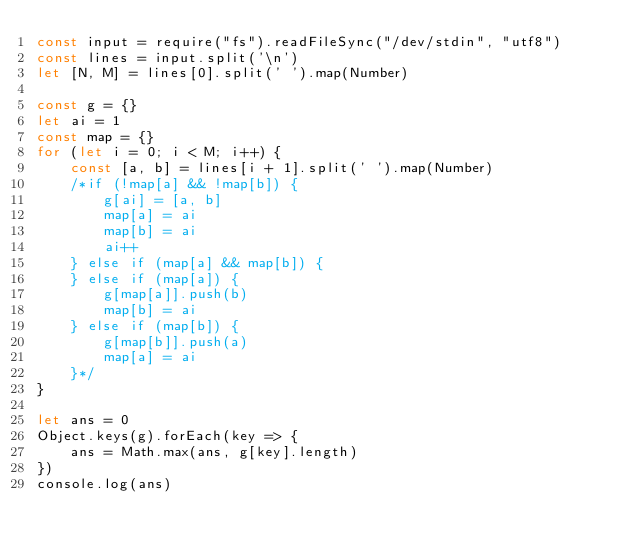Convert code to text. <code><loc_0><loc_0><loc_500><loc_500><_JavaScript_>const input = require("fs").readFileSync("/dev/stdin", "utf8")
const lines = input.split('\n')
let [N, M] = lines[0].split(' ').map(Number)

const g = {}
let ai = 1
const map = {}
for (let i = 0; i < M; i++) {
    const [a, b] = lines[i + 1].split(' ').map(Number)
    /*if (!map[a] && !map[b]) {
        g[ai] = [a, b]
        map[a] = ai
        map[b] = ai
        ai++
    } else if (map[a] && map[b]) {
    } else if (map[a]) {
        g[map[a]].push(b)
        map[b] = ai
    } else if (map[b]) {
        g[map[b]].push(a)
        map[a] = ai
    }*/
}

let ans = 0
Object.keys(g).forEach(key => {
    ans = Math.max(ans, g[key].length)
})
console.log(ans)
</code> 